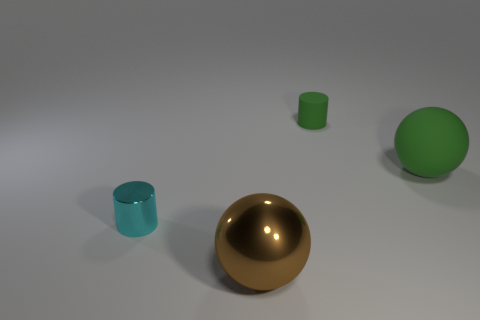Add 4 big purple metal spheres. How many objects exist? 8 Add 3 large brown shiny spheres. How many large brown shiny spheres are left? 4 Add 2 brown objects. How many brown objects exist? 3 Subtract 0 purple cylinders. How many objects are left? 4 Subtract all metallic cylinders. Subtract all purple cubes. How many objects are left? 3 